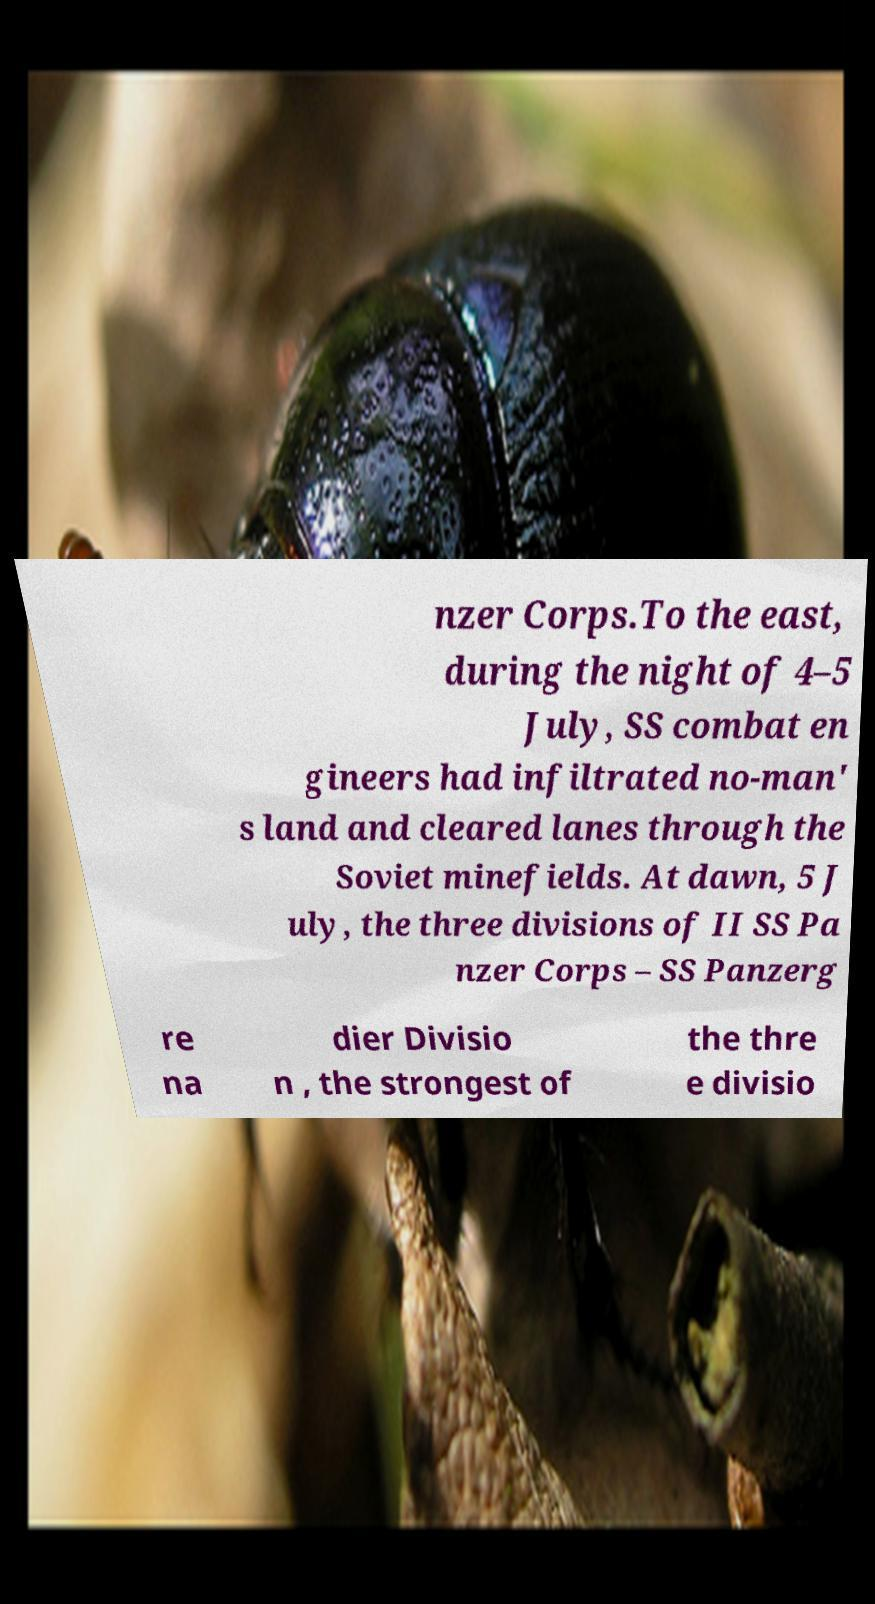Can you accurately transcribe the text from the provided image for me? nzer Corps.To the east, during the night of 4–5 July, SS combat en gineers had infiltrated no-man' s land and cleared lanes through the Soviet minefields. At dawn, 5 J uly, the three divisions of II SS Pa nzer Corps – SS Panzerg re na dier Divisio n , the strongest of the thre e divisio 